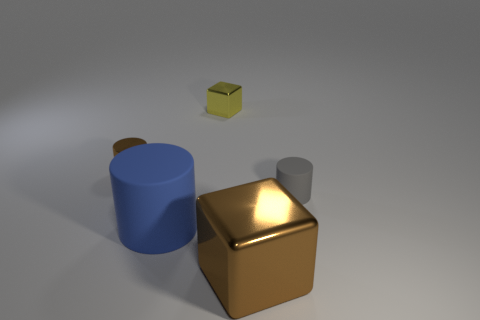What time of day does the lighting in this picture suggest? The lighting in the image gives a soft and diffused appearance, suggesting it could be either early morning or late afternoon, times when sunlight tends to be more golden and less intense, casting softer shadows. 